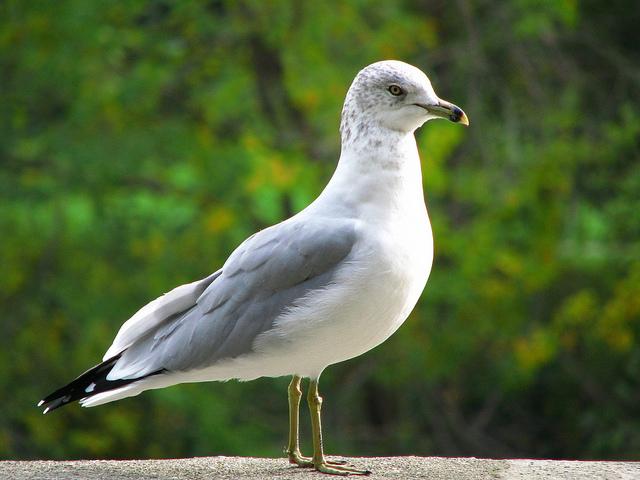How fast is the bird moving?
Be succinct. Not moving. What is the bird sitting on?
Short answer required. Concrete. What kind of bird is this?
Concise answer only. Seagull. Does the bird have something in it's mouth?
Answer briefly. No. What colors are in the birds' feathers?
Be succinct. White. What color is this bird?
Be succinct. White. What is in the background?
Write a very short answer. Trees. Does the bird have a shadow?
Give a very brief answer. No. 